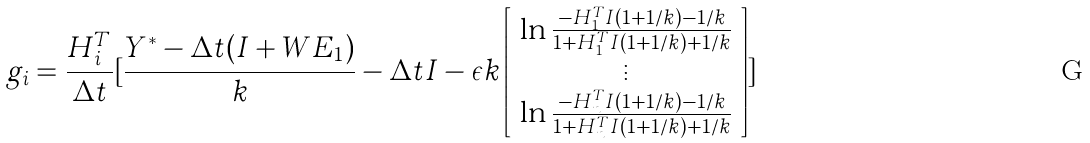Convert formula to latex. <formula><loc_0><loc_0><loc_500><loc_500>g _ { i } = \frac { H _ { i } ^ { T } } { \Delta t } [ \frac { Y ^ { * } - \Delta t ( I + W E _ { 1 } ) } { k } - \Delta t I - \epsilon k \left [ \begin{array} { c } \ln \frac { - H _ { 1 } ^ { T } I ( 1 + 1 / k ) - 1 / k } { 1 + H _ { 1 } ^ { T } I ( 1 + 1 / k ) + 1 / k } \\ \vdots \\ \ln \frac { - H _ { n } ^ { T } I ( 1 + 1 / k ) - 1 / k } { 1 + H _ { n } ^ { T } I ( 1 + 1 / k ) + 1 / k } \end{array} \right ] ]</formula> 